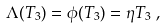Convert formula to latex. <formula><loc_0><loc_0><loc_500><loc_500>& \Lambda ( T _ { 3 } ) = \phi ( T _ { 3 } ) = \eta T _ { 3 } \ ,</formula> 